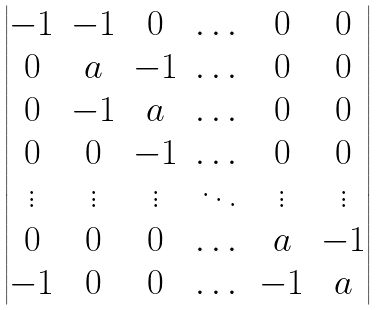<formula> <loc_0><loc_0><loc_500><loc_500>\begin{vmatrix} - 1 & - 1 & 0 & \dots & 0 & 0 \\ 0 & a & - 1 & \dots & 0 & 0 \\ 0 & - 1 & a & \dots & 0 & 0 \\ 0 & 0 & - 1 & \dots & 0 & 0 \\ \vdots & \vdots & \vdots & \ddots & \vdots & \vdots \\ 0 & 0 & 0 & \dots & a & - 1 \\ - 1 & 0 & 0 & \dots & - 1 & a \\ \end{vmatrix}</formula> 